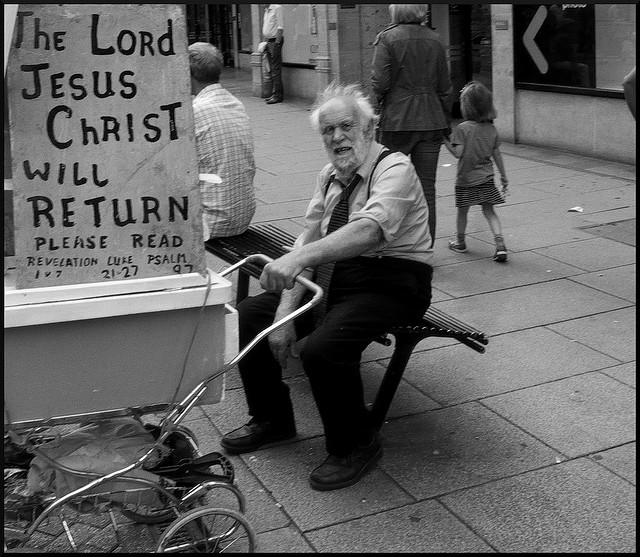What is the man doing?
Keep it brief. Sitting. Is this man homeless?
Quick response, please. No. What is the bench made of?
Write a very short answer. Metal. Do you think this man is a computer engineer?
Quick response, please. No. What is this man's profession?
Keep it brief. Preacher. Is the person wearing work uniform?
Concise answer only. No. What is the man sharing a bench with?
Give a very brief answer. Another man. What are the people pulling?
Give a very brief answer. Cart. What country is this?
Answer briefly. Usa. Is this picture in the United States?
Concise answer only. Yes. What is the function of the business behind the girl?
Concise answer only. Store. What nationality is the man that's sitting sideways in the chair?
Concise answer only. White. Is the man not wearing pants?
Quick response, please. No. What is on the boys back?
Concise answer only. Shirt. What knee is he leaning on?
Write a very short answer. Right. How many people are in this image?
Short answer required. 5. How many boards?
Be succinct. 1. What color is the crate behind the sign?
Keep it brief. White. Is anyone in this picture wearing sunglasses?
Keep it brief. No. Is this in America?
Answer briefly. Yes. What does the text read?
Answer briefly. Lord jesus christ will return please read. What is written on the image?
Keep it brief. Lord jesus christ will return. What material is the bench made of?
Short answer required. Metal. Is this an English speaking country?
Short answer required. Yes. Is he on a ship?
Keep it brief. No. Is this person interested in the large sign in the background?
Write a very short answer. No. What is the man sitting on?
Answer briefly. Bench. Does he have big feet?
Quick response, please. No. What is the man doing with his two legs?
Keep it brief. Sitting. Is this picture taken in the United States?
Give a very brief answer. Yes. Is the man standing or sitting?
Be succinct. Sitting. Is the man on a skateboard?
Keep it brief. No. What does the sign say is being imported?
Quick response, please. Nothing. 